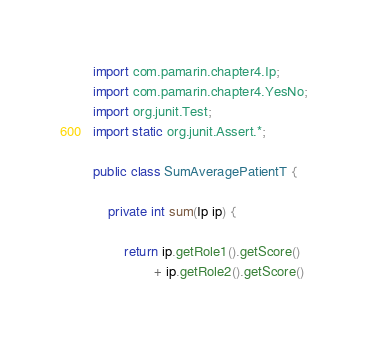<code> <loc_0><loc_0><loc_500><loc_500><_Java_>
import com.pamarin.chapter4.Ip;
import com.pamarin.chapter4.YesNo;
import org.junit.Test;
import static org.junit.Assert.*;

public class SumAveragePatientT {

    private int sum(Ip ip) {

        return ip.getRole1().getScore()
                + ip.getRole2().getScore()</code> 